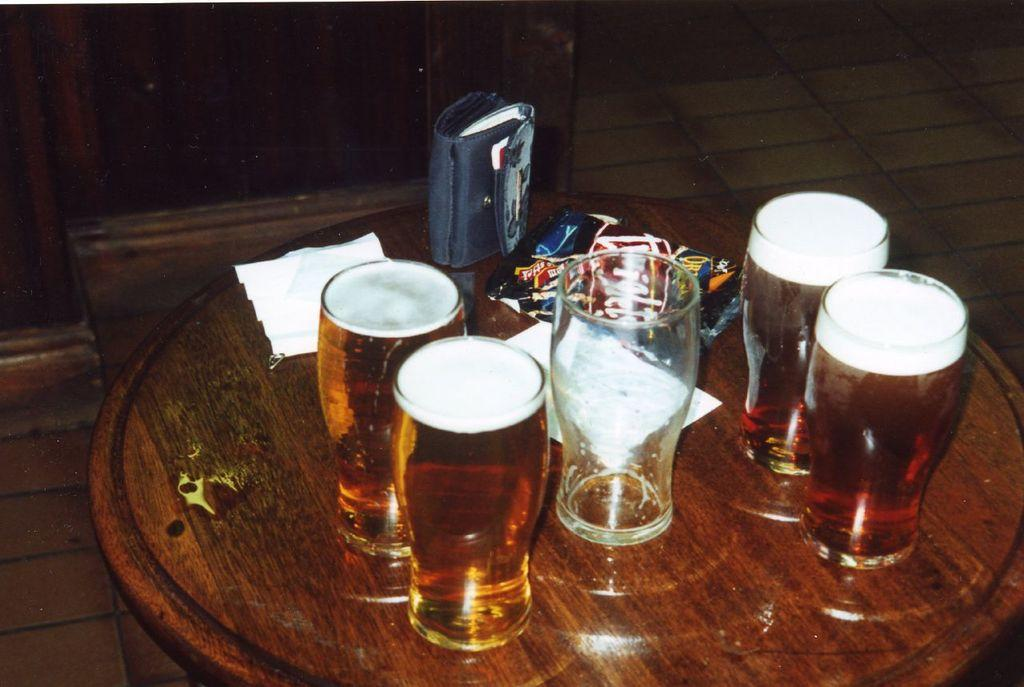How many glasses are visible in the image? There are five glasses in the image. What is the status of the drinks in the glasses? Four of the glasses are filled with a drink. What type of furniture is present in the image? There is a wooden table in the image. Where is the wooden table located? The wooden table is on the floor. What type of train is visible in the image? There is no train present in the image. How does the wealth of the individuals in the image contribute to the number of glasses? The wealth of the individuals in the image is not mentioned, and therefore it cannot be determined how it might contribute to the number of glasses. 